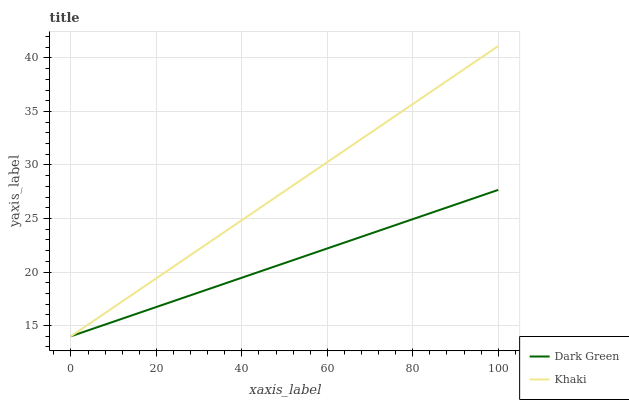Does Dark Green have the minimum area under the curve?
Answer yes or no. Yes. Does Khaki have the maximum area under the curve?
Answer yes or no. Yes. Does Dark Green have the maximum area under the curve?
Answer yes or no. No. Is Dark Green the smoothest?
Answer yes or no. Yes. Is Khaki the roughest?
Answer yes or no. Yes. Is Dark Green the roughest?
Answer yes or no. No. Does Khaki have the lowest value?
Answer yes or no. Yes. Does Khaki have the highest value?
Answer yes or no. Yes. Does Dark Green have the highest value?
Answer yes or no. No. Does Khaki intersect Dark Green?
Answer yes or no. Yes. Is Khaki less than Dark Green?
Answer yes or no. No. Is Khaki greater than Dark Green?
Answer yes or no. No. 